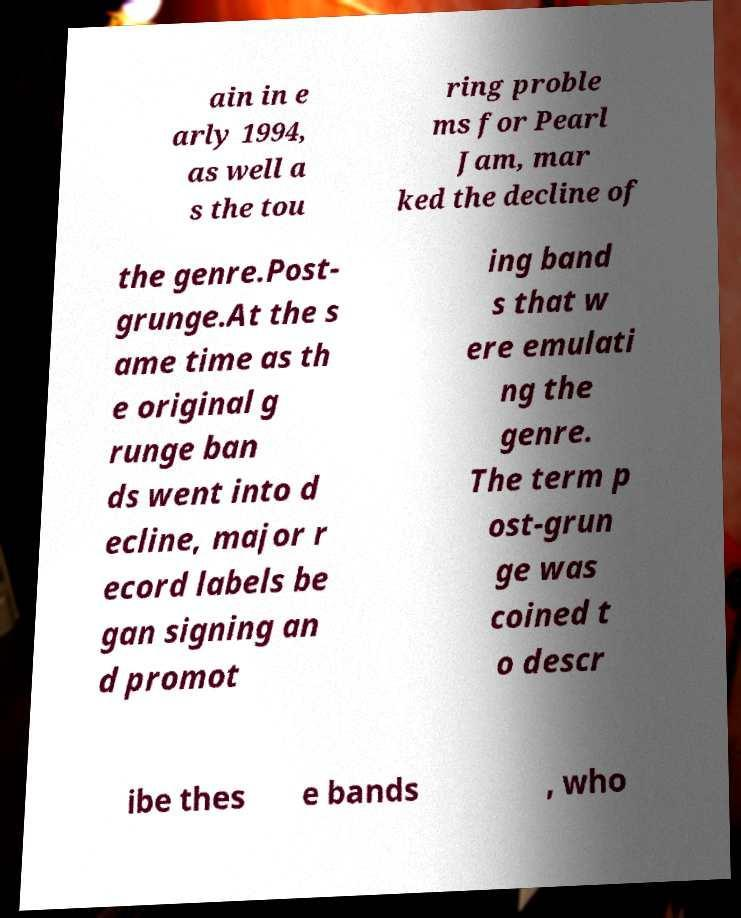Could you assist in decoding the text presented in this image and type it out clearly? ain in e arly 1994, as well a s the tou ring proble ms for Pearl Jam, mar ked the decline of the genre.Post- grunge.At the s ame time as th e original g runge ban ds went into d ecline, major r ecord labels be gan signing an d promot ing band s that w ere emulati ng the genre. The term p ost-grun ge was coined t o descr ibe thes e bands , who 